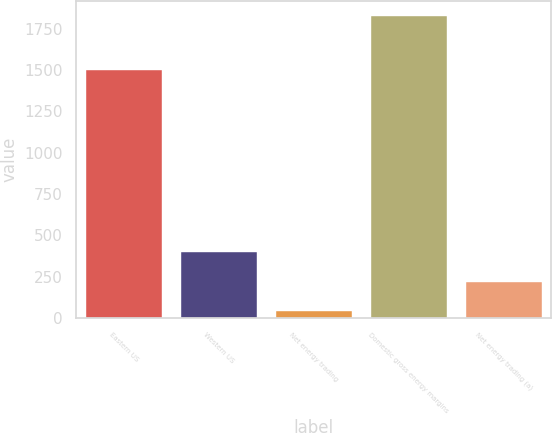Convert chart. <chart><loc_0><loc_0><loc_500><loc_500><bar_chart><fcel>Eastern US<fcel>Western US<fcel>Net energy trading<fcel>Domestic gross energy margins<fcel>Net energy trading (a)<nl><fcel>1502<fcel>397.6<fcel>41<fcel>1824<fcel>219.3<nl></chart> 